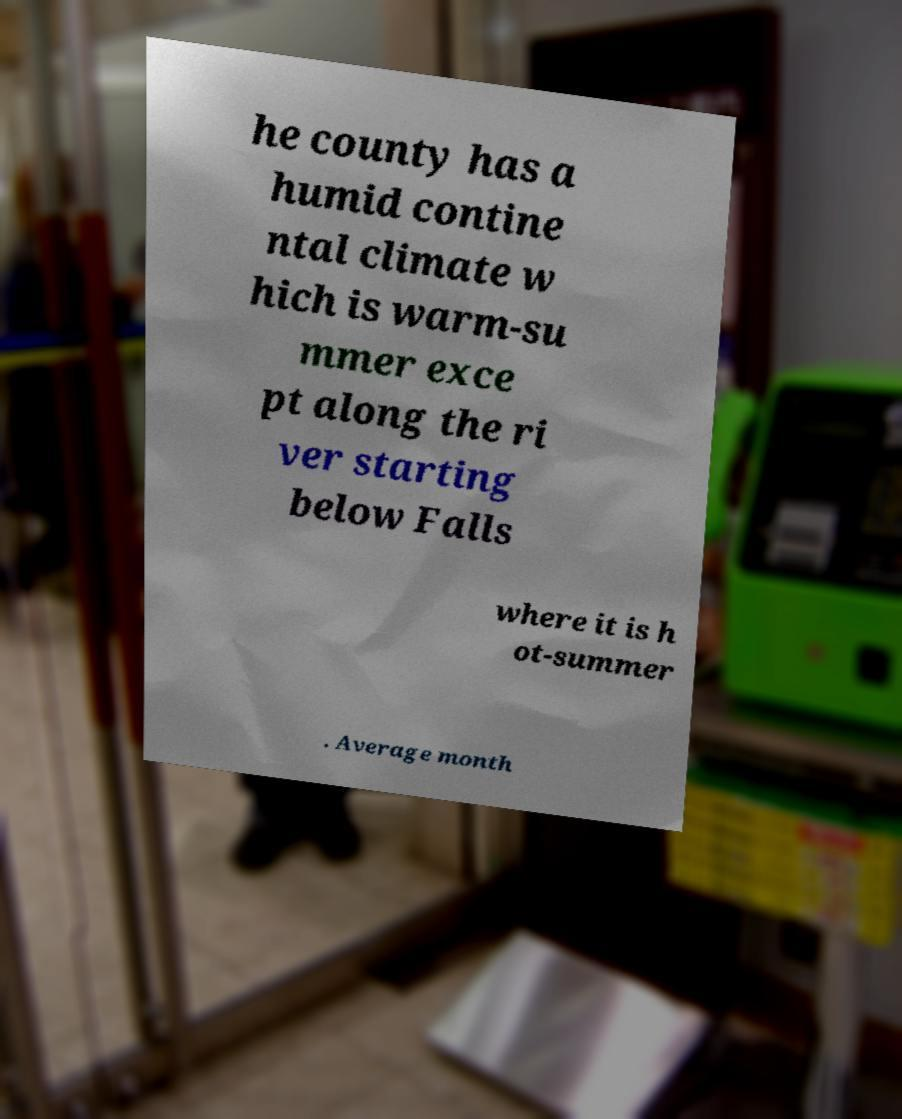Please read and relay the text visible in this image. What does it say? he county has a humid contine ntal climate w hich is warm-su mmer exce pt along the ri ver starting below Falls where it is h ot-summer . Average month 